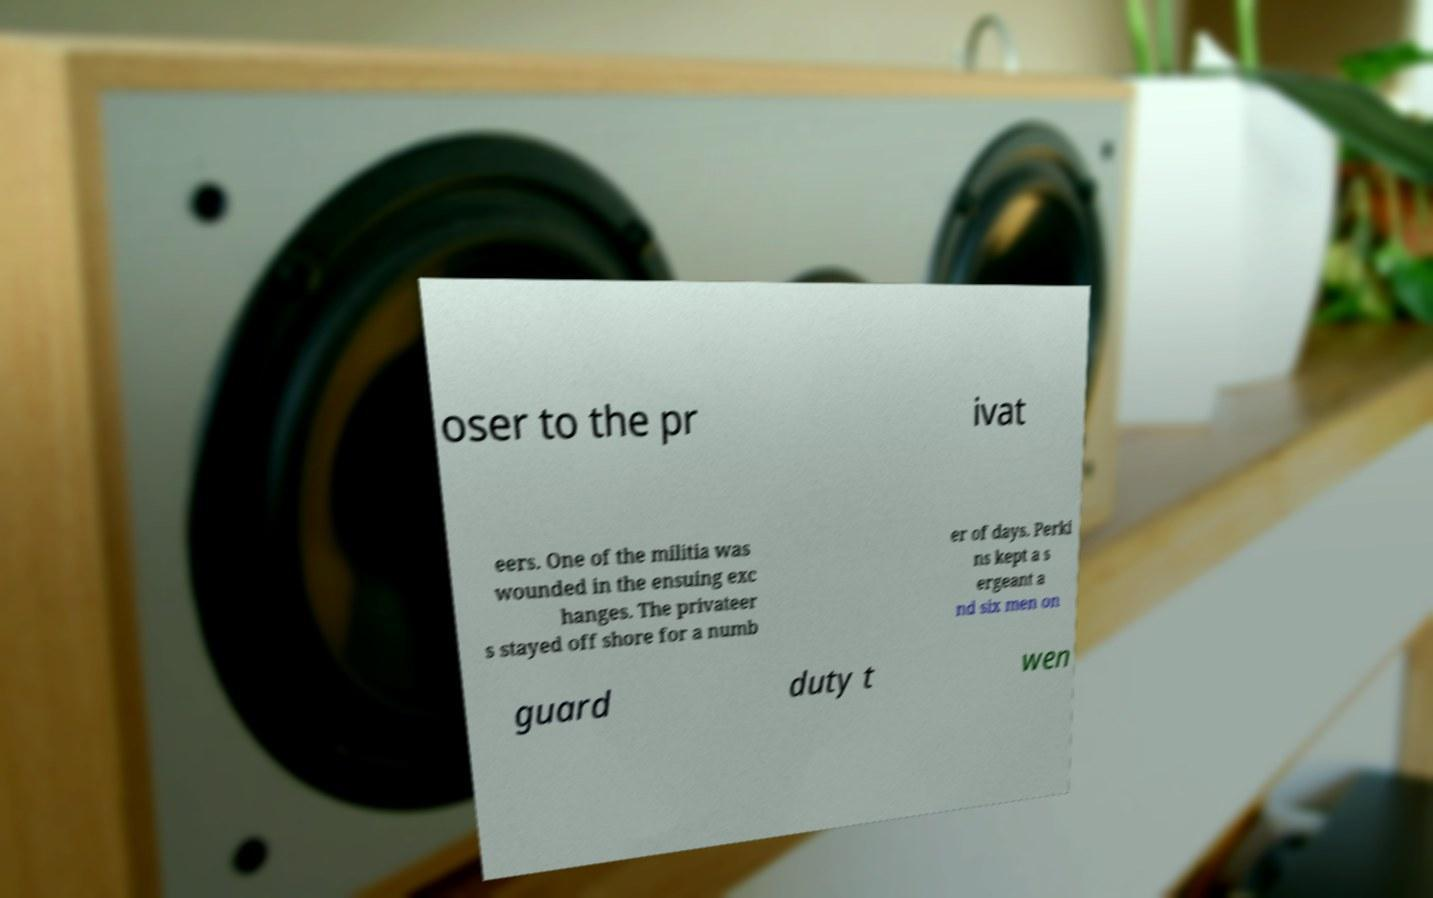I need the written content from this picture converted into text. Can you do that? oser to the pr ivat eers. One of the militia was wounded in the ensuing exc hanges. The privateer s stayed off shore for a numb er of days. Perki ns kept a s ergeant a nd six men on guard duty t wen 